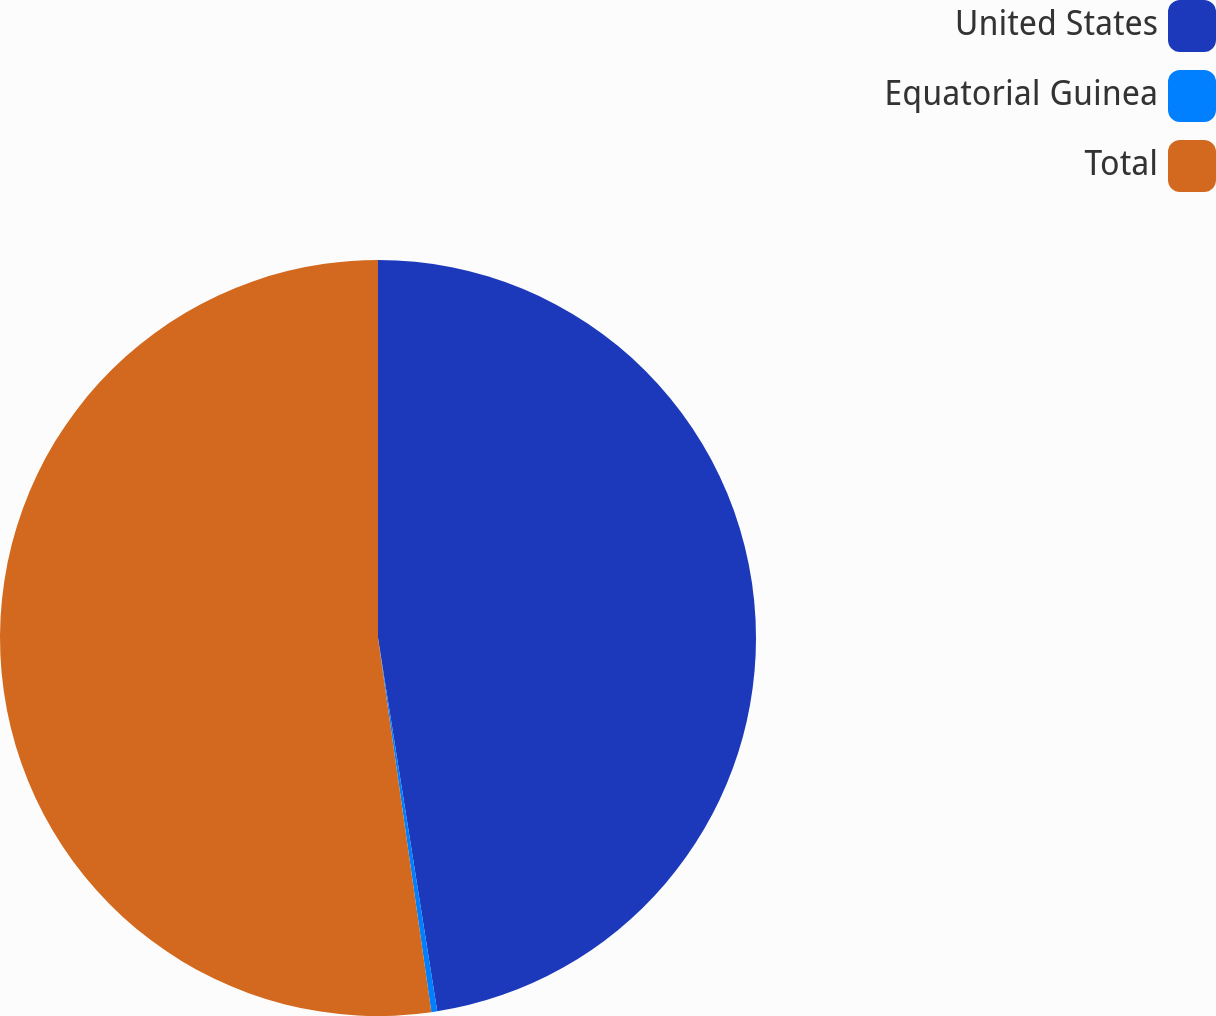Convert chart to OTSL. <chart><loc_0><loc_0><loc_500><loc_500><pie_chart><fcel>United States<fcel>Equatorial Guinea<fcel>Total<nl><fcel>47.5%<fcel>0.25%<fcel>52.26%<nl></chart> 